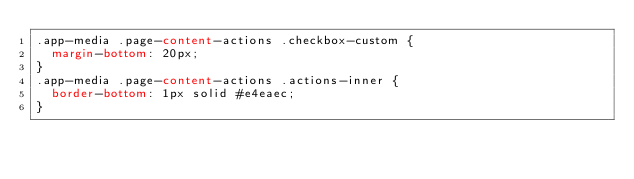Convert code to text. <code><loc_0><loc_0><loc_500><loc_500><_CSS_>.app-media .page-content-actions .checkbox-custom {
  margin-bottom: 20px;
}
.app-media .page-content-actions .actions-inner {
  border-bottom: 1px solid #e4eaec;
}</code> 